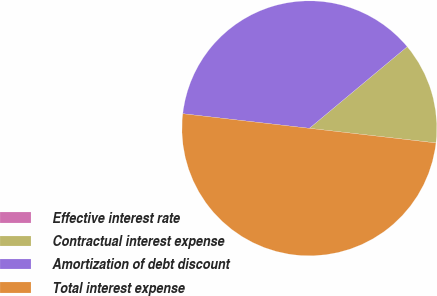Convert chart. <chart><loc_0><loc_0><loc_500><loc_500><pie_chart><fcel>Effective interest rate<fcel>Contractual interest expense<fcel>Amortization of debt discount<fcel>Total interest expense<nl><fcel>0.01%<fcel>12.89%<fcel>37.1%<fcel>49.99%<nl></chart> 